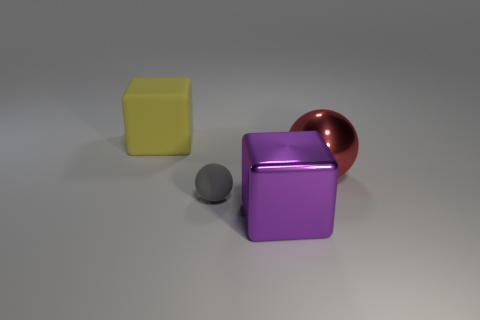What number of large objects are blue metal blocks or purple things?
Offer a very short reply. 1. Is there any other thing that is the same shape as the yellow thing?
Your answer should be compact. Yes. Is there any other thing that has the same size as the yellow cube?
Your response must be concise. Yes. There is a thing that is the same material as the large sphere; what is its color?
Give a very brief answer. Purple. There is a large block to the right of the yellow cube; what is its color?
Your answer should be compact. Purple. What number of tiny objects have the same color as the big metallic sphere?
Your response must be concise. 0. Are there fewer large red metallic things to the right of the red object than big purple blocks behind the small gray ball?
Offer a very short reply. No. How many purple blocks are behind the large metal cube?
Ensure brevity in your answer.  0. Are there any big balls that have the same material as the tiny thing?
Offer a very short reply. No. Are there more big red things that are behind the yellow block than matte balls that are behind the tiny object?
Offer a terse response. No. 